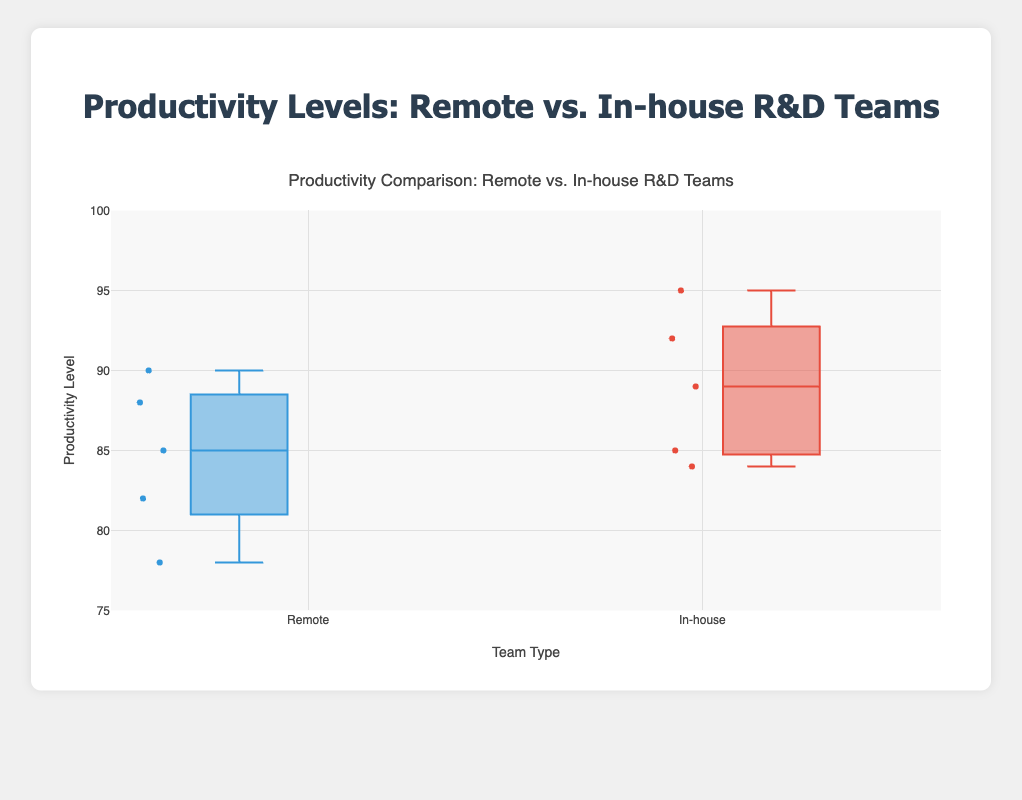What is the title of the box plot? The title is displayed prominently at the top of the figure. It indicates the main theme or the topic of the data being visualized.
Answer: Productivity Comparison: Remote vs. In-house R&D Teams What categories are compared in the box plot? There are two categories being compared in the box plot. These categories are labeled on the axis and through the legends.
Answer: Remote and In-house Which team type has a higher median productivity level? To determine which team type has a higher median productivity level, you should look at the central line within each box. The median is represented by this line.
Answer: In-house What is the productivity range for the remote teams? The productivity range can be found by looking at the bottom and top of the boxes and whiskers for the remote teams. This range includes both the lower and upper bounds of the data.
Answer: 78 to 90 How many data points are there for the In-house category? Each dot within the box plots represents a data point. By counting the dots within the "In-house" box plot, we can determine the number of data points.
Answer: 5 What is the interquartile range (IQR) for the remote teams? The IQR is determined by finding the difference between the third quartile (the top of the box) and the first quartile (the bottom of the box) for the remote teams.
Answer: 85 - 82 = 3 Which company has the highest productivity measurement in the remote category? The highest productivity measurement can be identified by finding the highest point within the remote category’s box and whisker plot. Look for the maximum value towards the top of the whiskers or outliers.
Answer: PSTech (90) Is there any overlap in the productivity levels between remote and in-house teams? To determine if there is an overlap, compare the ranges of the boxes and whiskers for both categories. If the ranges intersect or touch, there is an overlap.
Answer: Yes How does the variability of productivity levels compare between remote and in-house teams? The variability can be compared by looking at the length of the boxes (interquartile range) and the whiskers. Longer boxes and whiskers indicate higher variability.
Answer: Remote teams have higher variability 